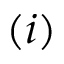<formula> <loc_0><loc_0><loc_500><loc_500>( i )</formula> 